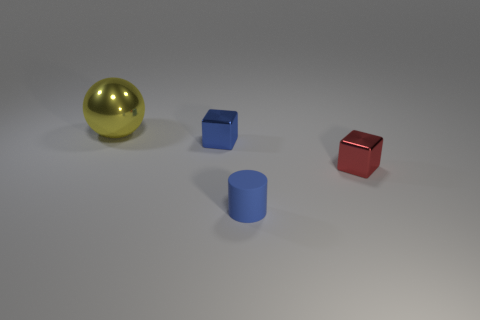Add 4 yellow balls. How many objects exist? 8 Subtract all spheres. How many objects are left? 3 Subtract 0 green cylinders. How many objects are left? 4 Subtract all tiny metallic cylinders. Subtract all blue cylinders. How many objects are left? 3 Add 1 rubber objects. How many rubber objects are left? 2 Add 2 shiny things. How many shiny things exist? 5 